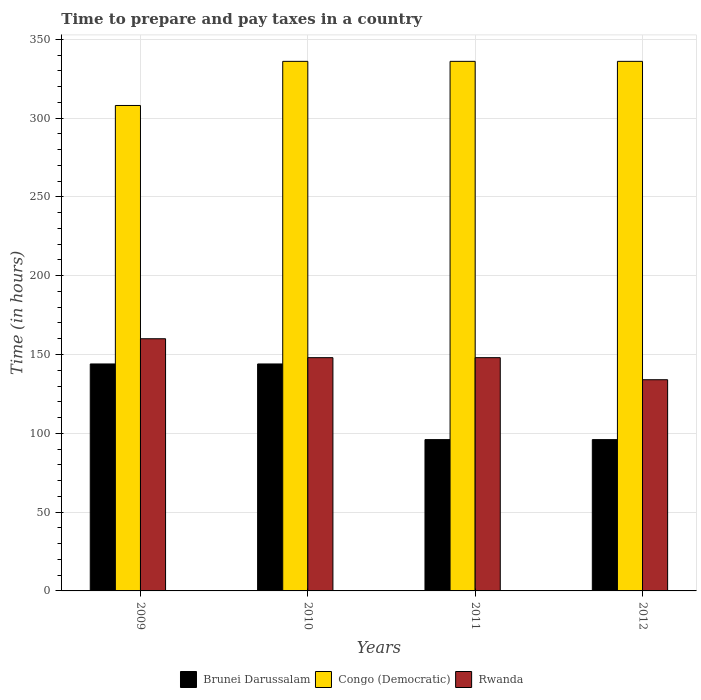How many different coloured bars are there?
Your answer should be compact. 3. Are the number of bars per tick equal to the number of legend labels?
Your response must be concise. Yes. Are the number of bars on each tick of the X-axis equal?
Make the answer very short. Yes. How many bars are there on the 1st tick from the right?
Offer a very short reply. 3. What is the label of the 2nd group of bars from the left?
Give a very brief answer. 2010. In how many cases, is the number of bars for a given year not equal to the number of legend labels?
Ensure brevity in your answer.  0. What is the number of hours required to prepare and pay taxes in Congo (Democratic) in 2009?
Provide a short and direct response. 308. Across all years, what is the maximum number of hours required to prepare and pay taxes in Congo (Democratic)?
Your response must be concise. 336. Across all years, what is the minimum number of hours required to prepare and pay taxes in Rwanda?
Offer a very short reply. 134. What is the total number of hours required to prepare and pay taxes in Rwanda in the graph?
Your response must be concise. 590. What is the difference between the number of hours required to prepare and pay taxes in Congo (Democratic) in 2011 and that in 2012?
Offer a very short reply. 0. What is the difference between the number of hours required to prepare and pay taxes in Congo (Democratic) in 2011 and the number of hours required to prepare and pay taxes in Rwanda in 2009?
Offer a terse response. 176. What is the average number of hours required to prepare and pay taxes in Rwanda per year?
Offer a very short reply. 147.5. In the year 2012, what is the difference between the number of hours required to prepare and pay taxes in Brunei Darussalam and number of hours required to prepare and pay taxes in Congo (Democratic)?
Keep it short and to the point. -240. In how many years, is the number of hours required to prepare and pay taxes in Brunei Darussalam greater than 170 hours?
Your answer should be very brief. 0. What is the ratio of the number of hours required to prepare and pay taxes in Rwanda in 2009 to that in 2012?
Offer a terse response. 1.19. Is the number of hours required to prepare and pay taxes in Rwanda in 2010 less than that in 2011?
Provide a short and direct response. No. Is the difference between the number of hours required to prepare and pay taxes in Brunei Darussalam in 2009 and 2012 greater than the difference between the number of hours required to prepare and pay taxes in Congo (Democratic) in 2009 and 2012?
Offer a very short reply. Yes. What is the difference between the highest and the second highest number of hours required to prepare and pay taxes in Rwanda?
Your answer should be very brief. 12. What is the difference between the highest and the lowest number of hours required to prepare and pay taxes in Brunei Darussalam?
Provide a succinct answer. 48. In how many years, is the number of hours required to prepare and pay taxes in Brunei Darussalam greater than the average number of hours required to prepare and pay taxes in Brunei Darussalam taken over all years?
Keep it short and to the point. 2. Is the sum of the number of hours required to prepare and pay taxes in Congo (Democratic) in 2009 and 2010 greater than the maximum number of hours required to prepare and pay taxes in Rwanda across all years?
Ensure brevity in your answer.  Yes. What does the 3rd bar from the left in 2012 represents?
Your answer should be compact. Rwanda. What does the 1st bar from the right in 2012 represents?
Provide a short and direct response. Rwanda. Is it the case that in every year, the sum of the number of hours required to prepare and pay taxes in Brunei Darussalam and number of hours required to prepare and pay taxes in Rwanda is greater than the number of hours required to prepare and pay taxes in Congo (Democratic)?
Provide a succinct answer. No. How many bars are there?
Keep it short and to the point. 12. Are all the bars in the graph horizontal?
Your answer should be compact. No. What is the difference between two consecutive major ticks on the Y-axis?
Make the answer very short. 50. How are the legend labels stacked?
Your answer should be very brief. Horizontal. What is the title of the graph?
Offer a terse response. Time to prepare and pay taxes in a country. What is the label or title of the X-axis?
Provide a short and direct response. Years. What is the label or title of the Y-axis?
Offer a very short reply. Time (in hours). What is the Time (in hours) of Brunei Darussalam in 2009?
Your response must be concise. 144. What is the Time (in hours) of Congo (Democratic) in 2009?
Your answer should be compact. 308. What is the Time (in hours) in Rwanda in 2009?
Offer a terse response. 160. What is the Time (in hours) in Brunei Darussalam in 2010?
Your answer should be very brief. 144. What is the Time (in hours) of Congo (Democratic) in 2010?
Keep it short and to the point. 336. What is the Time (in hours) of Rwanda in 2010?
Make the answer very short. 148. What is the Time (in hours) of Brunei Darussalam in 2011?
Your answer should be compact. 96. What is the Time (in hours) in Congo (Democratic) in 2011?
Your response must be concise. 336. What is the Time (in hours) in Rwanda in 2011?
Provide a short and direct response. 148. What is the Time (in hours) in Brunei Darussalam in 2012?
Keep it short and to the point. 96. What is the Time (in hours) in Congo (Democratic) in 2012?
Provide a short and direct response. 336. What is the Time (in hours) of Rwanda in 2012?
Make the answer very short. 134. Across all years, what is the maximum Time (in hours) in Brunei Darussalam?
Provide a short and direct response. 144. Across all years, what is the maximum Time (in hours) of Congo (Democratic)?
Keep it short and to the point. 336. Across all years, what is the maximum Time (in hours) in Rwanda?
Ensure brevity in your answer.  160. Across all years, what is the minimum Time (in hours) in Brunei Darussalam?
Ensure brevity in your answer.  96. Across all years, what is the minimum Time (in hours) in Congo (Democratic)?
Your answer should be very brief. 308. Across all years, what is the minimum Time (in hours) of Rwanda?
Offer a terse response. 134. What is the total Time (in hours) in Brunei Darussalam in the graph?
Your answer should be compact. 480. What is the total Time (in hours) in Congo (Democratic) in the graph?
Make the answer very short. 1316. What is the total Time (in hours) in Rwanda in the graph?
Your response must be concise. 590. What is the difference between the Time (in hours) in Rwanda in 2009 and that in 2010?
Give a very brief answer. 12. What is the difference between the Time (in hours) of Brunei Darussalam in 2009 and that in 2012?
Offer a terse response. 48. What is the difference between the Time (in hours) in Congo (Democratic) in 2010 and that in 2011?
Keep it short and to the point. 0. What is the difference between the Time (in hours) of Rwanda in 2010 and that in 2011?
Give a very brief answer. 0. What is the difference between the Time (in hours) of Brunei Darussalam in 2011 and that in 2012?
Provide a short and direct response. 0. What is the difference between the Time (in hours) in Brunei Darussalam in 2009 and the Time (in hours) in Congo (Democratic) in 2010?
Offer a very short reply. -192. What is the difference between the Time (in hours) in Congo (Democratic) in 2009 and the Time (in hours) in Rwanda in 2010?
Offer a terse response. 160. What is the difference between the Time (in hours) of Brunei Darussalam in 2009 and the Time (in hours) of Congo (Democratic) in 2011?
Offer a very short reply. -192. What is the difference between the Time (in hours) of Congo (Democratic) in 2009 and the Time (in hours) of Rwanda in 2011?
Make the answer very short. 160. What is the difference between the Time (in hours) in Brunei Darussalam in 2009 and the Time (in hours) in Congo (Democratic) in 2012?
Your answer should be compact. -192. What is the difference between the Time (in hours) in Brunei Darussalam in 2009 and the Time (in hours) in Rwanda in 2012?
Your answer should be compact. 10. What is the difference between the Time (in hours) in Congo (Democratic) in 2009 and the Time (in hours) in Rwanda in 2012?
Provide a succinct answer. 174. What is the difference between the Time (in hours) in Brunei Darussalam in 2010 and the Time (in hours) in Congo (Democratic) in 2011?
Keep it short and to the point. -192. What is the difference between the Time (in hours) of Brunei Darussalam in 2010 and the Time (in hours) of Rwanda in 2011?
Your answer should be very brief. -4. What is the difference between the Time (in hours) of Congo (Democratic) in 2010 and the Time (in hours) of Rwanda in 2011?
Ensure brevity in your answer.  188. What is the difference between the Time (in hours) in Brunei Darussalam in 2010 and the Time (in hours) in Congo (Democratic) in 2012?
Provide a succinct answer. -192. What is the difference between the Time (in hours) in Congo (Democratic) in 2010 and the Time (in hours) in Rwanda in 2012?
Provide a short and direct response. 202. What is the difference between the Time (in hours) of Brunei Darussalam in 2011 and the Time (in hours) of Congo (Democratic) in 2012?
Your response must be concise. -240. What is the difference between the Time (in hours) of Brunei Darussalam in 2011 and the Time (in hours) of Rwanda in 2012?
Provide a succinct answer. -38. What is the difference between the Time (in hours) of Congo (Democratic) in 2011 and the Time (in hours) of Rwanda in 2012?
Ensure brevity in your answer.  202. What is the average Time (in hours) of Brunei Darussalam per year?
Provide a short and direct response. 120. What is the average Time (in hours) in Congo (Democratic) per year?
Give a very brief answer. 329. What is the average Time (in hours) of Rwanda per year?
Your answer should be very brief. 147.5. In the year 2009, what is the difference between the Time (in hours) of Brunei Darussalam and Time (in hours) of Congo (Democratic)?
Your answer should be very brief. -164. In the year 2009, what is the difference between the Time (in hours) of Brunei Darussalam and Time (in hours) of Rwanda?
Keep it short and to the point. -16. In the year 2009, what is the difference between the Time (in hours) of Congo (Democratic) and Time (in hours) of Rwanda?
Ensure brevity in your answer.  148. In the year 2010, what is the difference between the Time (in hours) in Brunei Darussalam and Time (in hours) in Congo (Democratic)?
Make the answer very short. -192. In the year 2010, what is the difference between the Time (in hours) in Congo (Democratic) and Time (in hours) in Rwanda?
Offer a terse response. 188. In the year 2011, what is the difference between the Time (in hours) of Brunei Darussalam and Time (in hours) of Congo (Democratic)?
Offer a terse response. -240. In the year 2011, what is the difference between the Time (in hours) of Brunei Darussalam and Time (in hours) of Rwanda?
Offer a terse response. -52. In the year 2011, what is the difference between the Time (in hours) of Congo (Democratic) and Time (in hours) of Rwanda?
Give a very brief answer. 188. In the year 2012, what is the difference between the Time (in hours) in Brunei Darussalam and Time (in hours) in Congo (Democratic)?
Your answer should be very brief. -240. In the year 2012, what is the difference between the Time (in hours) of Brunei Darussalam and Time (in hours) of Rwanda?
Make the answer very short. -38. In the year 2012, what is the difference between the Time (in hours) of Congo (Democratic) and Time (in hours) of Rwanda?
Your answer should be compact. 202. What is the ratio of the Time (in hours) of Congo (Democratic) in 2009 to that in 2010?
Your answer should be very brief. 0.92. What is the ratio of the Time (in hours) in Rwanda in 2009 to that in 2010?
Give a very brief answer. 1.08. What is the ratio of the Time (in hours) in Rwanda in 2009 to that in 2011?
Your response must be concise. 1.08. What is the ratio of the Time (in hours) of Brunei Darussalam in 2009 to that in 2012?
Your answer should be very brief. 1.5. What is the ratio of the Time (in hours) of Congo (Democratic) in 2009 to that in 2012?
Provide a succinct answer. 0.92. What is the ratio of the Time (in hours) in Rwanda in 2009 to that in 2012?
Your response must be concise. 1.19. What is the ratio of the Time (in hours) of Brunei Darussalam in 2010 to that in 2011?
Give a very brief answer. 1.5. What is the ratio of the Time (in hours) of Rwanda in 2010 to that in 2012?
Provide a succinct answer. 1.1. What is the ratio of the Time (in hours) in Congo (Democratic) in 2011 to that in 2012?
Your response must be concise. 1. What is the ratio of the Time (in hours) in Rwanda in 2011 to that in 2012?
Your answer should be very brief. 1.1. What is the difference between the highest and the second highest Time (in hours) of Brunei Darussalam?
Offer a very short reply. 0. What is the difference between the highest and the second highest Time (in hours) of Congo (Democratic)?
Your response must be concise. 0. What is the difference between the highest and the lowest Time (in hours) in Brunei Darussalam?
Offer a very short reply. 48. 